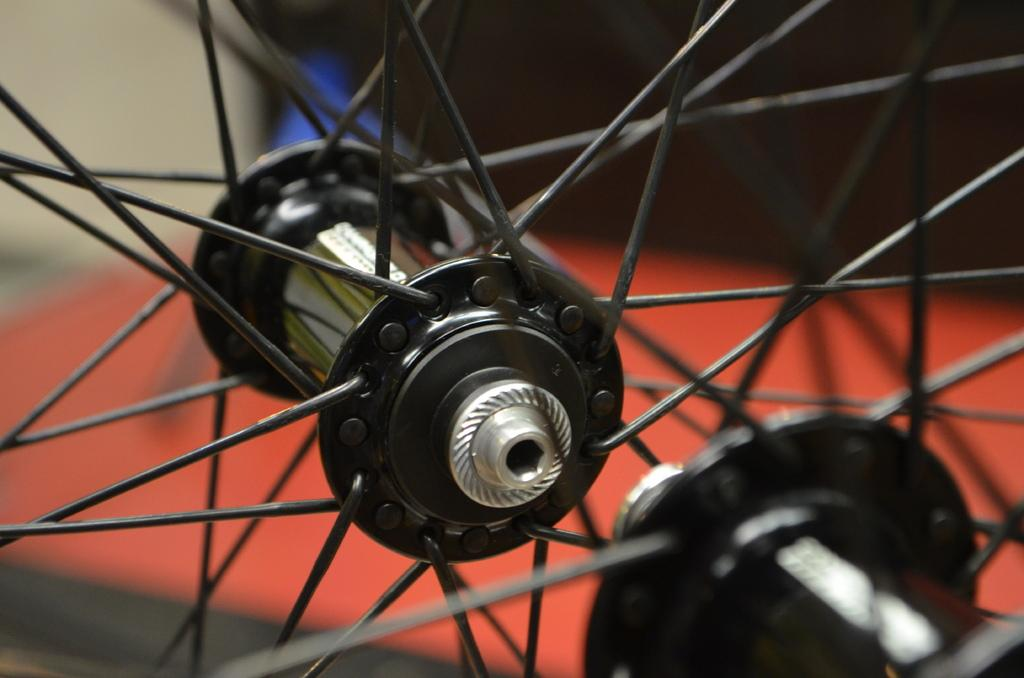How many rims can be seen in the image? There are two rims in the image. What colors are the objects behind the rims? There is a red colored object and a blue colored object behind the rims. How many tickets are visible in the image? There are no tickets present in the image. Are there any flowers visible in the image? There are no flowers present in the image. 